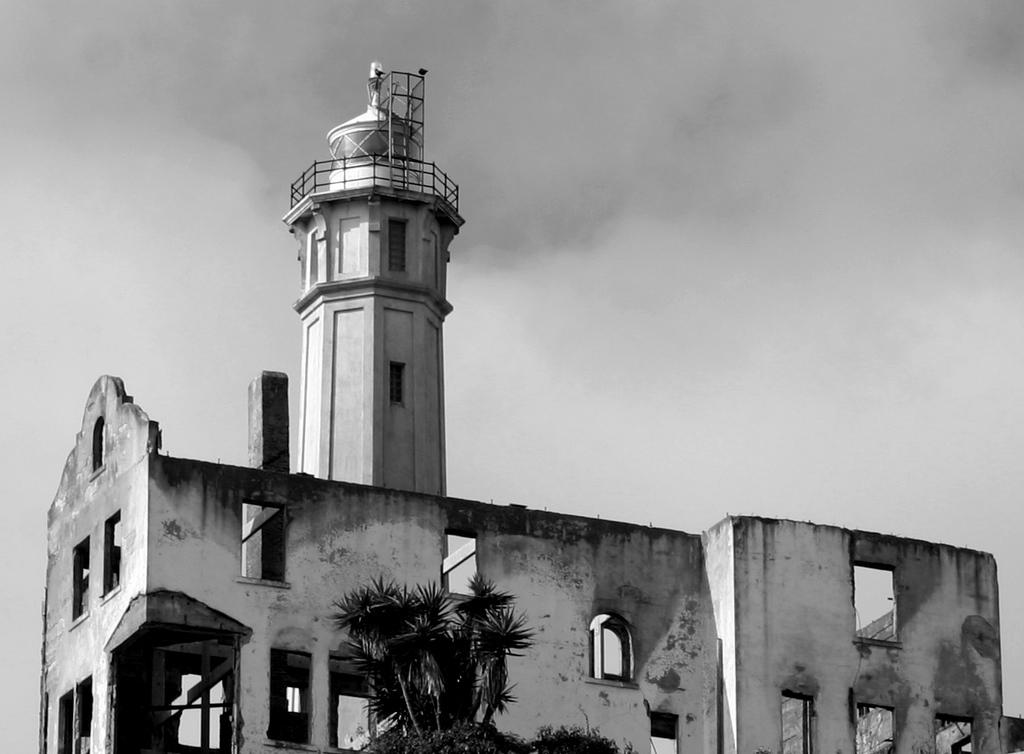What is the main structure in the center of the image? There is a tower in the center of the image. What other object can be seen at the bottom of the image? There is a tree at the bottom of the image. What can be seen in the background of the image? The sky is visible in the background of the image. What type of range can be seen in the image? There is no range present in the image; it features a tower and a tree. Who is the writer of the image? The image is not a written work, so there is no writer associated with it. 